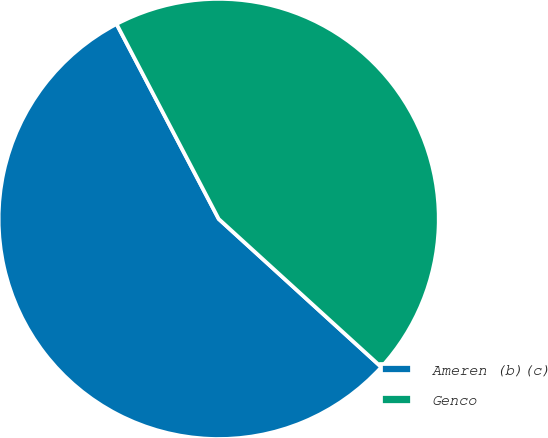Convert chart. <chart><loc_0><loc_0><loc_500><loc_500><pie_chart><fcel>Ameren (b)(c)<fcel>Genco<nl><fcel>55.56%<fcel>44.44%<nl></chart> 